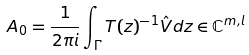<formula> <loc_0><loc_0><loc_500><loc_500>A _ { 0 } = \frac { 1 } { 2 \pi i } \int _ { \Gamma } T ( z ) ^ { - 1 } \hat { V } d z \in \mathbb { C } ^ { m , l }</formula> 